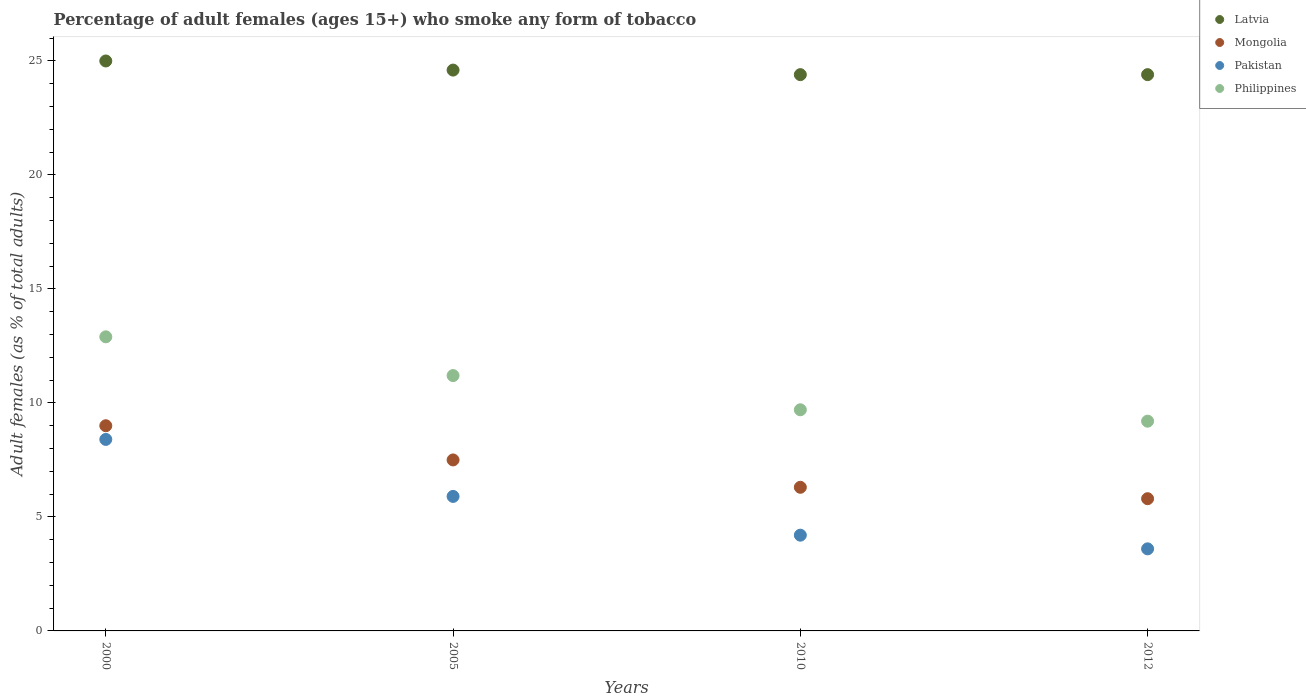Is the number of dotlines equal to the number of legend labels?
Your answer should be very brief. Yes. In which year was the percentage of adult females who smoke in Latvia maximum?
Provide a short and direct response. 2000. What is the total percentage of adult females who smoke in Mongolia in the graph?
Give a very brief answer. 28.6. What is the difference between the percentage of adult females who smoke in Pakistan in 2005 and that in 2010?
Ensure brevity in your answer.  1.7. What is the difference between the percentage of adult females who smoke in Pakistan in 2000 and the percentage of adult females who smoke in Mongolia in 2012?
Provide a short and direct response. 2.6. What is the average percentage of adult females who smoke in Latvia per year?
Your response must be concise. 24.6. In the year 2012, what is the difference between the percentage of adult females who smoke in Philippines and percentage of adult females who smoke in Pakistan?
Make the answer very short. 5.6. What is the ratio of the percentage of adult females who smoke in Mongolia in 2000 to that in 2010?
Make the answer very short. 1.43. Is the percentage of adult females who smoke in Latvia in 2005 less than that in 2012?
Your answer should be compact. No. Is the difference between the percentage of adult females who smoke in Philippines in 2000 and 2012 greater than the difference between the percentage of adult females who smoke in Pakistan in 2000 and 2012?
Offer a very short reply. No. What is the difference between the highest and the lowest percentage of adult females who smoke in Mongolia?
Provide a short and direct response. 3.2. Is the sum of the percentage of adult females who smoke in Mongolia in 2005 and 2010 greater than the maximum percentage of adult females who smoke in Philippines across all years?
Give a very brief answer. Yes. Does the percentage of adult females who smoke in Latvia monotonically increase over the years?
Offer a very short reply. No. Does the graph contain grids?
Provide a short and direct response. No. What is the title of the graph?
Ensure brevity in your answer.  Percentage of adult females (ages 15+) who smoke any form of tobacco. Does "Iraq" appear as one of the legend labels in the graph?
Provide a succinct answer. No. What is the label or title of the Y-axis?
Give a very brief answer. Adult females (as % of total adults). What is the Adult females (as % of total adults) in Latvia in 2000?
Give a very brief answer. 25. What is the Adult females (as % of total adults) in Pakistan in 2000?
Keep it short and to the point. 8.4. What is the Adult females (as % of total adults) in Philippines in 2000?
Keep it short and to the point. 12.9. What is the Adult females (as % of total adults) in Latvia in 2005?
Your answer should be very brief. 24.6. What is the Adult females (as % of total adults) of Pakistan in 2005?
Provide a short and direct response. 5.9. What is the Adult females (as % of total adults) of Philippines in 2005?
Your answer should be compact. 11.2. What is the Adult females (as % of total adults) in Latvia in 2010?
Provide a short and direct response. 24.4. What is the Adult females (as % of total adults) of Latvia in 2012?
Provide a succinct answer. 24.4. What is the Adult females (as % of total adults) in Mongolia in 2012?
Provide a succinct answer. 5.8. What is the Adult females (as % of total adults) of Pakistan in 2012?
Provide a short and direct response. 3.6. Across all years, what is the maximum Adult females (as % of total adults) of Mongolia?
Make the answer very short. 9. Across all years, what is the minimum Adult females (as % of total adults) in Latvia?
Your answer should be compact. 24.4. Across all years, what is the minimum Adult females (as % of total adults) in Mongolia?
Ensure brevity in your answer.  5.8. What is the total Adult females (as % of total adults) in Latvia in the graph?
Give a very brief answer. 98.4. What is the total Adult females (as % of total adults) of Mongolia in the graph?
Keep it short and to the point. 28.6. What is the total Adult females (as % of total adults) of Pakistan in the graph?
Make the answer very short. 22.1. What is the difference between the Adult females (as % of total adults) in Philippines in 2000 and that in 2005?
Offer a terse response. 1.7. What is the difference between the Adult females (as % of total adults) in Mongolia in 2000 and that in 2010?
Offer a very short reply. 2.7. What is the difference between the Adult females (as % of total adults) of Pakistan in 2000 and that in 2010?
Your response must be concise. 4.2. What is the difference between the Adult females (as % of total adults) in Latvia in 2000 and that in 2012?
Your answer should be compact. 0.6. What is the difference between the Adult females (as % of total adults) in Mongolia in 2000 and that in 2012?
Keep it short and to the point. 3.2. What is the difference between the Adult females (as % of total adults) in Philippines in 2000 and that in 2012?
Your answer should be compact. 3.7. What is the difference between the Adult females (as % of total adults) of Mongolia in 2005 and that in 2010?
Make the answer very short. 1.2. What is the difference between the Adult females (as % of total adults) of Mongolia in 2005 and that in 2012?
Provide a short and direct response. 1.7. What is the difference between the Adult females (as % of total adults) in Mongolia in 2010 and that in 2012?
Give a very brief answer. 0.5. What is the difference between the Adult females (as % of total adults) in Pakistan in 2010 and that in 2012?
Give a very brief answer. 0.6. What is the difference between the Adult females (as % of total adults) of Philippines in 2010 and that in 2012?
Give a very brief answer. 0.5. What is the difference between the Adult females (as % of total adults) of Latvia in 2000 and the Adult females (as % of total adults) of Mongolia in 2005?
Give a very brief answer. 17.5. What is the difference between the Adult females (as % of total adults) of Mongolia in 2000 and the Adult females (as % of total adults) of Pakistan in 2005?
Offer a terse response. 3.1. What is the difference between the Adult females (as % of total adults) of Pakistan in 2000 and the Adult females (as % of total adults) of Philippines in 2005?
Your answer should be very brief. -2.8. What is the difference between the Adult females (as % of total adults) in Latvia in 2000 and the Adult females (as % of total adults) in Pakistan in 2010?
Your answer should be very brief. 20.8. What is the difference between the Adult females (as % of total adults) of Mongolia in 2000 and the Adult females (as % of total adults) of Philippines in 2010?
Offer a terse response. -0.7. What is the difference between the Adult females (as % of total adults) in Latvia in 2000 and the Adult females (as % of total adults) in Pakistan in 2012?
Your answer should be very brief. 21.4. What is the difference between the Adult females (as % of total adults) of Latvia in 2000 and the Adult females (as % of total adults) of Philippines in 2012?
Give a very brief answer. 15.8. What is the difference between the Adult females (as % of total adults) in Mongolia in 2000 and the Adult females (as % of total adults) in Pakistan in 2012?
Offer a terse response. 5.4. What is the difference between the Adult females (as % of total adults) of Pakistan in 2000 and the Adult females (as % of total adults) of Philippines in 2012?
Ensure brevity in your answer.  -0.8. What is the difference between the Adult females (as % of total adults) in Latvia in 2005 and the Adult females (as % of total adults) in Mongolia in 2010?
Your answer should be compact. 18.3. What is the difference between the Adult females (as % of total adults) of Latvia in 2005 and the Adult females (as % of total adults) of Pakistan in 2010?
Make the answer very short. 20.4. What is the difference between the Adult females (as % of total adults) in Latvia in 2005 and the Adult females (as % of total adults) in Philippines in 2010?
Offer a terse response. 14.9. What is the difference between the Adult females (as % of total adults) of Mongolia in 2005 and the Adult females (as % of total adults) of Philippines in 2010?
Your answer should be very brief. -2.2. What is the difference between the Adult females (as % of total adults) in Pakistan in 2005 and the Adult females (as % of total adults) in Philippines in 2010?
Offer a terse response. -3.8. What is the difference between the Adult females (as % of total adults) of Latvia in 2010 and the Adult females (as % of total adults) of Pakistan in 2012?
Keep it short and to the point. 20.8. What is the difference between the Adult females (as % of total adults) of Mongolia in 2010 and the Adult females (as % of total adults) of Pakistan in 2012?
Keep it short and to the point. 2.7. What is the average Adult females (as % of total adults) of Latvia per year?
Your answer should be very brief. 24.6. What is the average Adult females (as % of total adults) of Mongolia per year?
Give a very brief answer. 7.15. What is the average Adult females (as % of total adults) of Pakistan per year?
Your answer should be compact. 5.53. What is the average Adult females (as % of total adults) in Philippines per year?
Your response must be concise. 10.75. In the year 2000, what is the difference between the Adult females (as % of total adults) of Latvia and Adult females (as % of total adults) of Pakistan?
Provide a short and direct response. 16.6. In the year 2000, what is the difference between the Adult females (as % of total adults) in Latvia and Adult females (as % of total adults) in Philippines?
Keep it short and to the point. 12.1. In the year 2000, what is the difference between the Adult females (as % of total adults) of Mongolia and Adult females (as % of total adults) of Philippines?
Your answer should be very brief. -3.9. In the year 2000, what is the difference between the Adult females (as % of total adults) in Pakistan and Adult females (as % of total adults) in Philippines?
Ensure brevity in your answer.  -4.5. In the year 2005, what is the difference between the Adult females (as % of total adults) of Latvia and Adult females (as % of total adults) of Mongolia?
Make the answer very short. 17.1. In the year 2005, what is the difference between the Adult females (as % of total adults) in Latvia and Adult females (as % of total adults) in Pakistan?
Your response must be concise. 18.7. In the year 2010, what is the difference between the Adult females (as % of total adults) in Latvia and Adult females (as % of total adults) in Pakistan?
Your response must be concise. 20.2. In the year 2010, what is the difference between the Adult females (as % of total adults) of Latvia and Adult females (as % of total adults) of Philippines?
Your response must be concise. 14.7. In the year 2012, what is the difference between the Adult females (as % of total adults) in Latvia and Adult females (as % of total adults) in Mongolia?
Your answer should be very brief. 18.6. In the year 2012, what is the difference between the Adult females (as % of total adults) of Latvia and Adult females (as % of total adults) of Pakistan?
Offer a terse response. 20.8. In the year 2012, what is the difference between the Adult females (as % of total adults) in Mongolia and Adult females (as % of total adults) in Philippines?
Keep it short and to the point. -3.4. In the year 2012, what is the difference between the Adult females (as % of total adults) in Pakistan and Adult females (as % of total adults) in Philippines?
Provide a short and direct response. -5.6. What is the ratio of the Adult females (as % of total adults) of Latvia in 2000 to that in 2005?
Provide a succinct answer. 1.02. What is the ratio of the Adult females (as % of total adults) of Pakistan in 2000 to that in 2005?
Ensure brevity in your answer.  1.42. What is the ratio of the Adult females (as % of total adults) of Philippines in 2000 to that in 2005?
Your answer should be very brief. 1.15. What is the ratio of the Adult females (as % of total adults) of Latvia in 2000 to that in 2010?
Your answer should be very brief. 1.02. What is the ratio of the Adult females (as % of total adults) in Mongolia in 2000 to that in 2010?
Provide a short and direct response. 1.43. What is the ratio of the Adult females (as % of total adults) of Philippines in 2000 to that in 2010?
Your answer should be compact. 1.33. What is the ratio of the Adult females (as % of total adults) in Latvia in 2000 to that in 2012?
Offer a very short reply. 1.02. What is the ratio of the Adult females (as % of total adults) in Mongolia in 2000 to that in 2012?
Give a very brief answer. 1.55. What is the ratio of the Adult females (as % of total adults) of Pakistan in 2000 to that in 2012?
Your answer should be compact. 2.33. What is the ratio of the Adult females (as % of total adults) in Philippines in 2000 to that in 2012?
Provide a short and direct response. 1.4. What is the ratio of the Adult females (as % of total adults) of Latvia in 2005 to that in 2010?
Offer a very short reply. 1.01. What is the ratio of the Adult females (as % of total adults) in Mongolia in 2005 to that in 2010?
Offer a very short reply. 1.19. What is the ratio of the Adult females (as % of total adults) in Pakistan in 2005 to that in 2010?
Ensure brevity in your answer.  1.4. What is the ratio of the Adult females (as % of total adults) of Philippines in 2005 to that in 2010?
Your answer should be compact. 1.15. What is the ratio of the Adult females (as % of total adults) in Latvia in 2005 to that in 2012?
Offer a terse response. 1.01. What is the ratio of the Adult females (as % of total adults) of Mongolia in 2005 to that in 2012?
Your response must be concise. 1.29. What is the ratio of the Adult females (as % of total adults) in Pakistan in 2005 to that in 2012?
Ensure brevity in your answer.  1.64. What is the ratio of the Adult females (as % of total adults) of Philippines in 2005 to that in 2012?
Provide a short and direct response. 1.22. What is the ratio of the Adult females (as % of total adults) of Mongolia in 2010 to that in 2012?
Ensure brevity in your answer.  1.09. What is the ratio of the Adult females (as % of total adults) in Pakistan in 2010 to that in 2012?
Provide a short and direct response. 1.17. What is the ratio of the Adult females (as % of total adults) of Philippines in 2010 to that in 2012?
Keep it short and to the point. 1.05. What is the difference between the highest and the second highest Adult females (as % of total adults) of Pakistan?
Offer a very short reply. 2.5. What is the difference between the highest and the lowest Adult females (as % of total adults) in Mongolia?
Offer a very short reply. 3.2. What is the difference between the highest and the lowest Adult females (as % of total adults) in Pakistan?
Make the answer very short. 4.8. What is the difference between the highest and the lowest Adult females (as % of total adults) of Philippines?
Your answer should be compact. 3.7. 